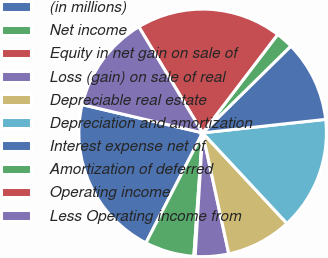Convert chart. <chart><loc_0><loc_0><loc_500><loc_500><pie_chart><fcel>(in millions)<fcel>Net income<fcel>Equity in net gain on sale of<fcel>Loss (gain) on sale of real<fcel>Depreciable real estate<fcel>Depreciation and amortization<fcel>Interest expense net of<fcel>Amortization of deferred<fcel>Operating income<fcel>Less Operating income from<nl><fcel>21.09%<fcel>6.44%<fcel>0.17%<fcel>4.35%<fcel>8.54%<fcel>14.81%<fcel>10.63%<fcel>2.26%<fcel>18.99%<fcel>12.72%<nl></chart> 